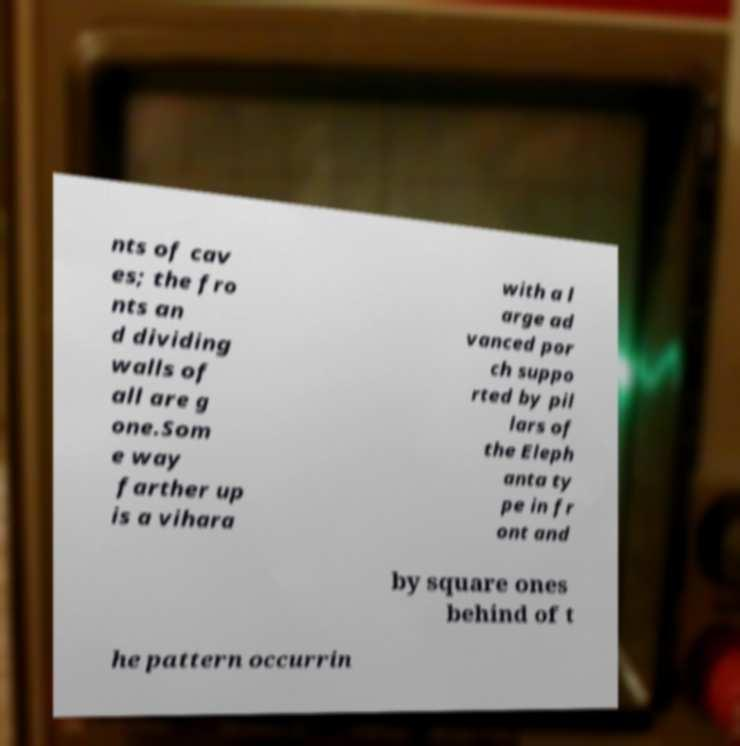Please read and relay the text visible in this image. What does it say? nts of cav es; the fro nts an d dividing walls of all are g one.Som e way farther up is a vihara with a l arge ad vanced por ch suppo rted by pil lars of the Eleph anta ty pe in fr ont and by square ones behind of t he pattern occurrin 